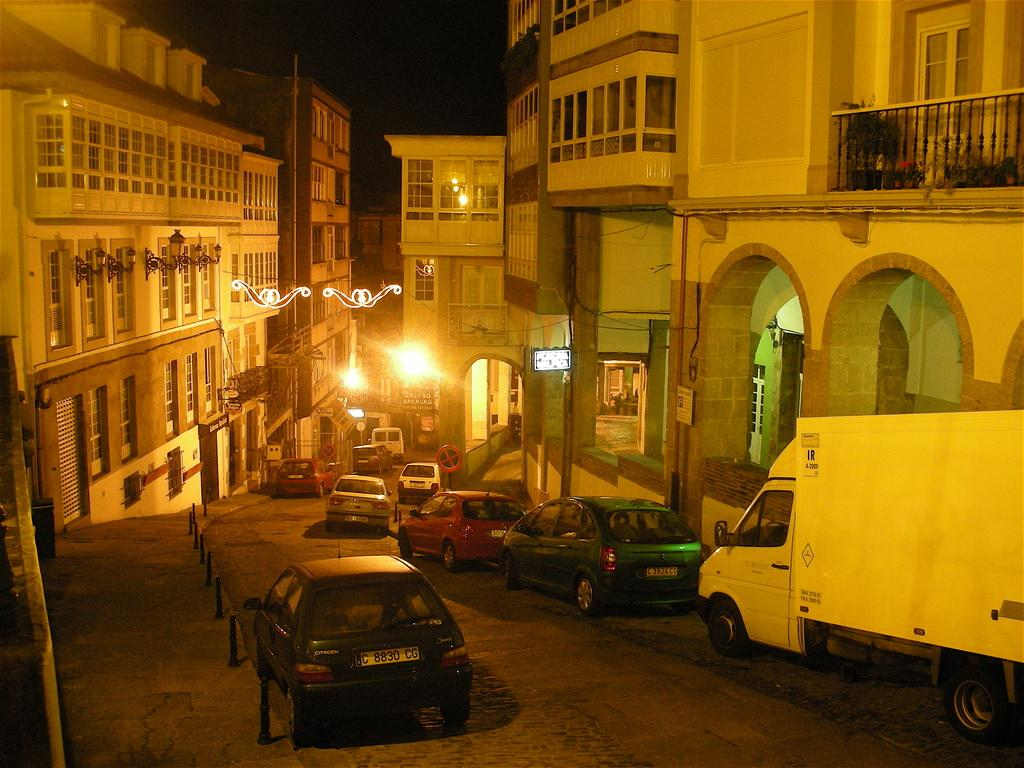What type of structures can be seen in the image? There are buildings in the image. What else is present in the image besides buildings? Vehicles, windows, poles, a grille, potted plants, lights, and boards with text are visible in the image. Can you describe the ship that is docked near the buildings in the image? There is no ship present in the image; it only features buildings, vehicles, windows, poles, a grille, potted plants, lights, and boards with text. 